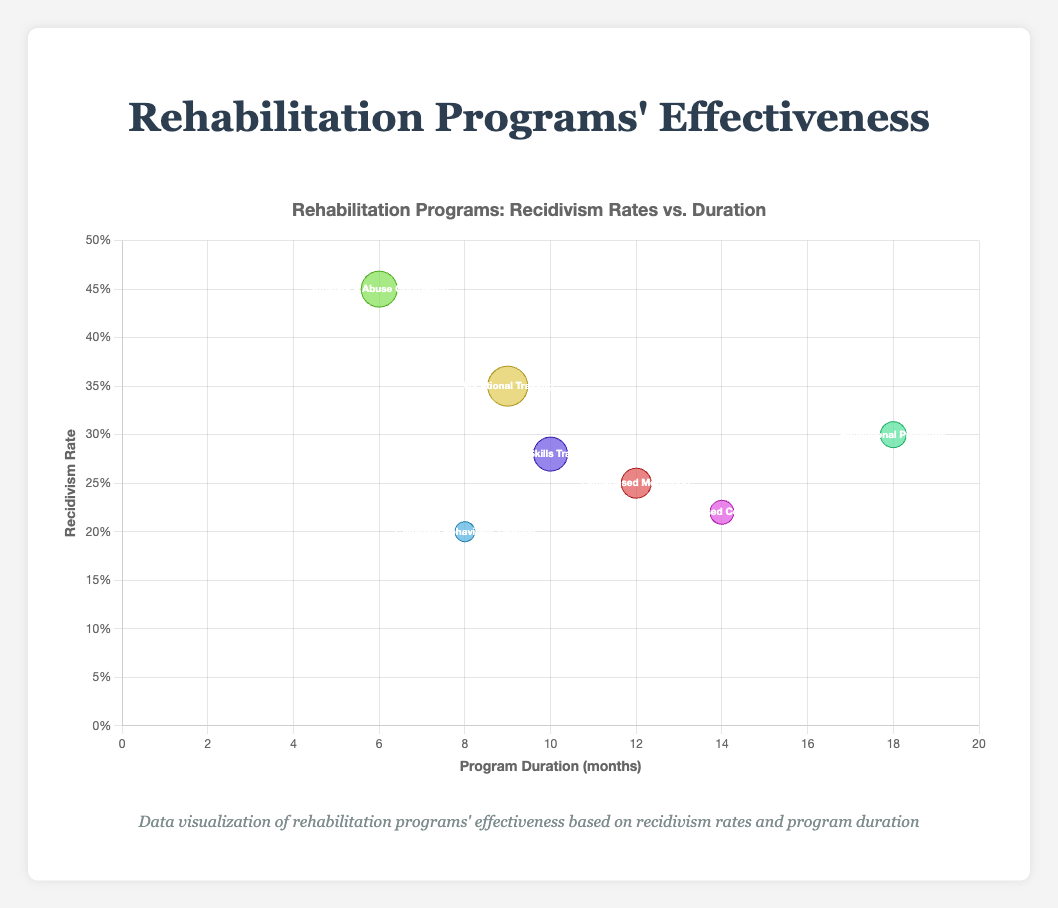How many rehabilitation programs are depicted in the bubble chart? Count the number of distinct bubbles in the chart, each representing a different rehabilitation program.
Answer: 7 Which rehabilitation program has the highest number of participants? Check the bubbles' sizes to find the largest one, as size reflects the number of participants.
Answer: Vocational Training What is the recidivism rate for Cognitive Behavioral Therapy? Identify the bubble for Cognitive Behavioral Therapy and read its position on the y-axis, which indicates the recidivism rate.
Answer: 0.20 Which program has the longest duration, and what is its duration? Locate the bubble farthest to the right on the x-axis to determine the program with the longest duration.
Answer: Educational Programs, 18 months Compare the recidivism rates between Faith-Based Mentoring and Faith-Based Counseling. Which one is lower? Check the y-axis positions of Faith-Based Mentoring and Faith-Based Counseling bubbles to compare their recidivism rates.
Answer: Faith-Based Counseling What is the average duration of all the programs? Sum the durations of all programs and divide by the total number of programs. Calculation: (12 + 9 + 6 + 18 + 8 + 10 + 14) / 7
Answer: 11 months How do the recidivism rates compare between programs with durations longer than 12 months and those with durations 12 months or shorter? Identify programs based on their duration, then compare their average recidivism rates. Long durations: Educational (0.30), Faith-Based Counseling (0.22); Short/Equal durations: Faith-Based Mentoring (0.25), Vocational (0.35), Substance Abuse (0.45), Cognitive Behavioral (0.20), Life Skills (0.28). Calculation: Long (0.30 + 0.22) / 2 = 0.26; Short/Equal (0.25 + 0.35 + 0.45 + 0.20 + 0.28) / 5 = 0.306.
Answer: Longer durations: 0.26, Shorter/Equal durations: 0.306 Which organization runs the program with the lowest recidivism rate, and what is the program's duration? Find the lowest point on the y-axis and check the corresponding bubble's duration and organization.
Answer: Mindful Healing, 8 months How does the number of participants in Life Skills Training compare to that in Faith-Based Mentoring? Compare the sizes of the bubbles representing Life Skills Training and Faith-Based Mentoring.
Answer: Life Skills Training has 20 more participants Which program by New Hope Ministries has what recidivism rate and duration? Find the bubble for New Hope Ministries and read its y-axis position (recidivism rate) and x-axis position (duration).
Answer: Recidivism rate: 0.25, Duration: 12 months 